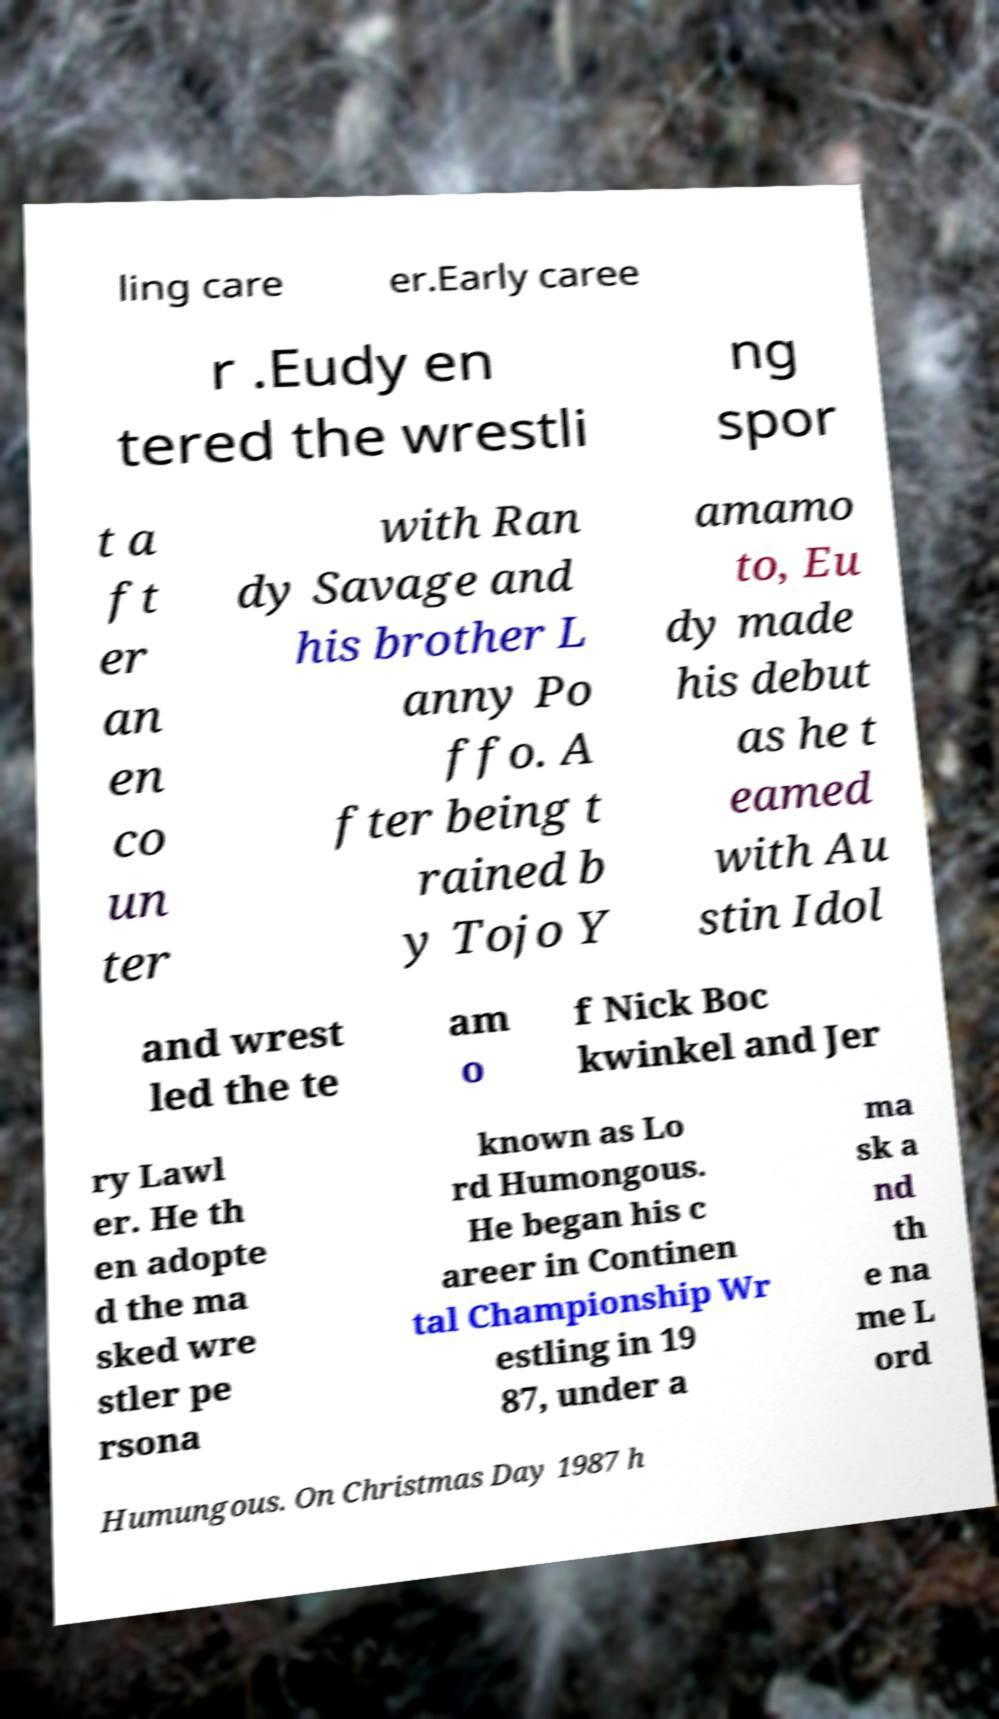For documentation purposes, I need the text within this image transcribed. Could you provide that? ling care er.Early caree r .Eudy en tered the wrestli ng spor t a ft er an en co un ter with Ran dy Savage and his brother L anny Po ffo. A fter being t rained b y Tojo Y amamo to, Eu dy made his debut as he t eamed with Au stin Idol and wrest led the te am o f Nick Boc kwinkel and Jer ry Lawl er. He th en adopte d the ma sked wre stler pe rsona known as Lo rd Humongous. He began his c areer in Continen tal Championship Wr estling in 19 87, under a ma sk a nd th e na me L ord Humungous. On Christmas Day 1987 h 